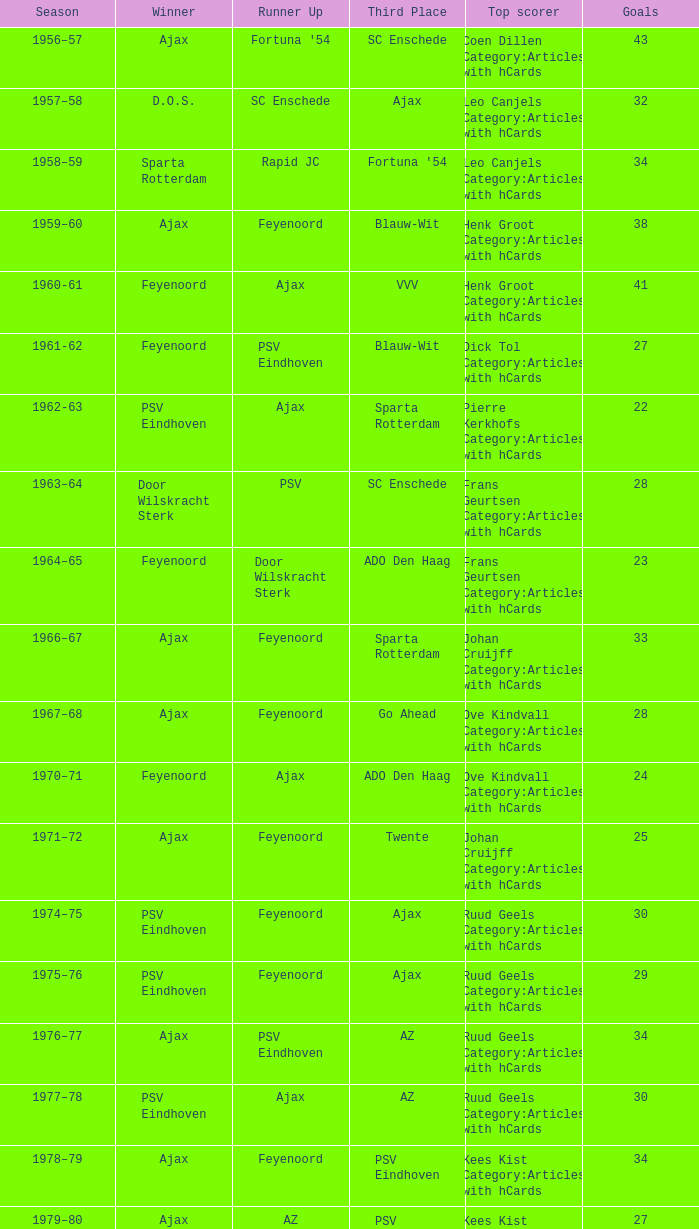When psv eindhoven claimed the victory and nac breda ranked third, who scored the most goals? Klaas-Jan Huntelaar Category:Articles with hCards. 